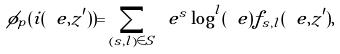<formula> <loc_0><loc_0><loc_500><loc_500>\phi _ { p } ( i ( \ e , z ^ { \prime } ) ) = \sum _ { ( s , l ) \in S } \ e ^ { s } \log ^ { l } ( \ e ) f _ { s , l } ( \ e , z ^ { \prime } ) ,</formula> 